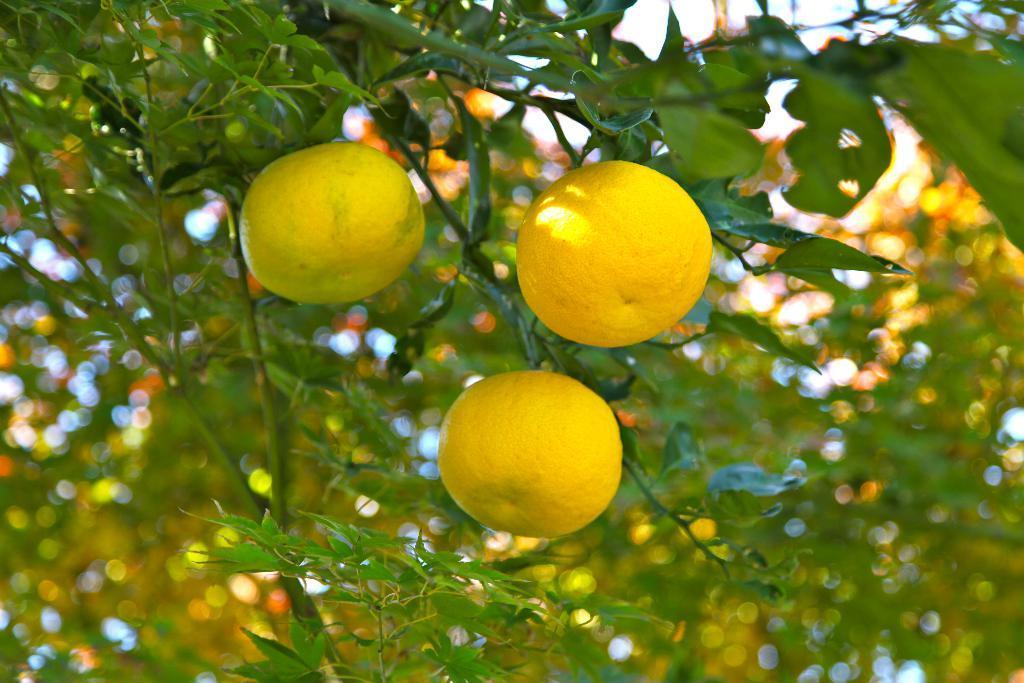Could you give a brief overview of what you see in this image? In this image I can see a tree which is green in color and to the tree I can see three fruits which are yellow in color. In the background I can see a tree which is green and orange in color and the sky. 